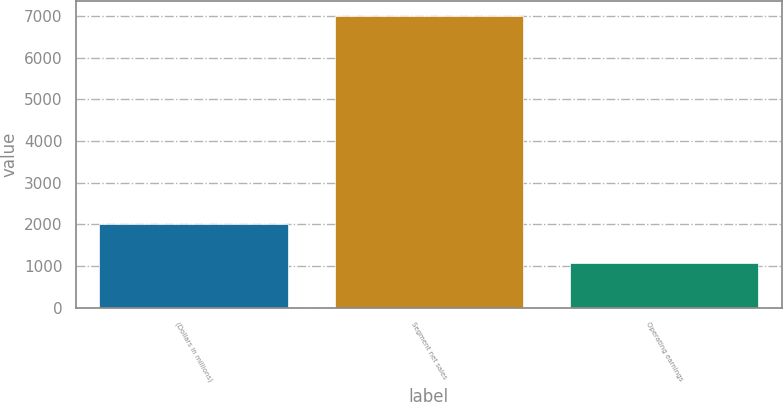Convert chart to OTSL. <chart><loc_0><loc_0><loc_500><loc_500><bar_chart><fcel>(Dollars in millions)<fcel>Segment net sales<fcel>Operating earnings<nl><fcel>2009<fcel>7008<fcel>1057<nl></chart> 